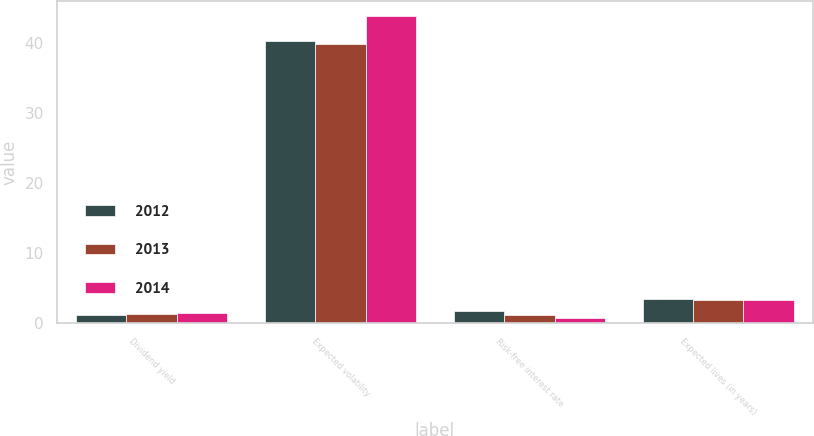Convert chart to OTSL. <chart><loc_0><loc_0><loc_500><loc_500><stacked_bar_chart><ecel><fcel>Dividend yield<fcel>Expected volatility<fcel>Risk-free interest rate<fcel>Expected lives (in years)<nl><fcel>2012<fcel>1.19<fcel>40.27<fcel>1.78<fcel>3.43<nl><fcel>2013<fcel>1.34<fcel>39.88<fcel>1.16<fcel>3.32<nl><fcel>2014<fcel>1.52<fcel>43.84<fcel>0.73<fcel>3.27<nl></chart> 